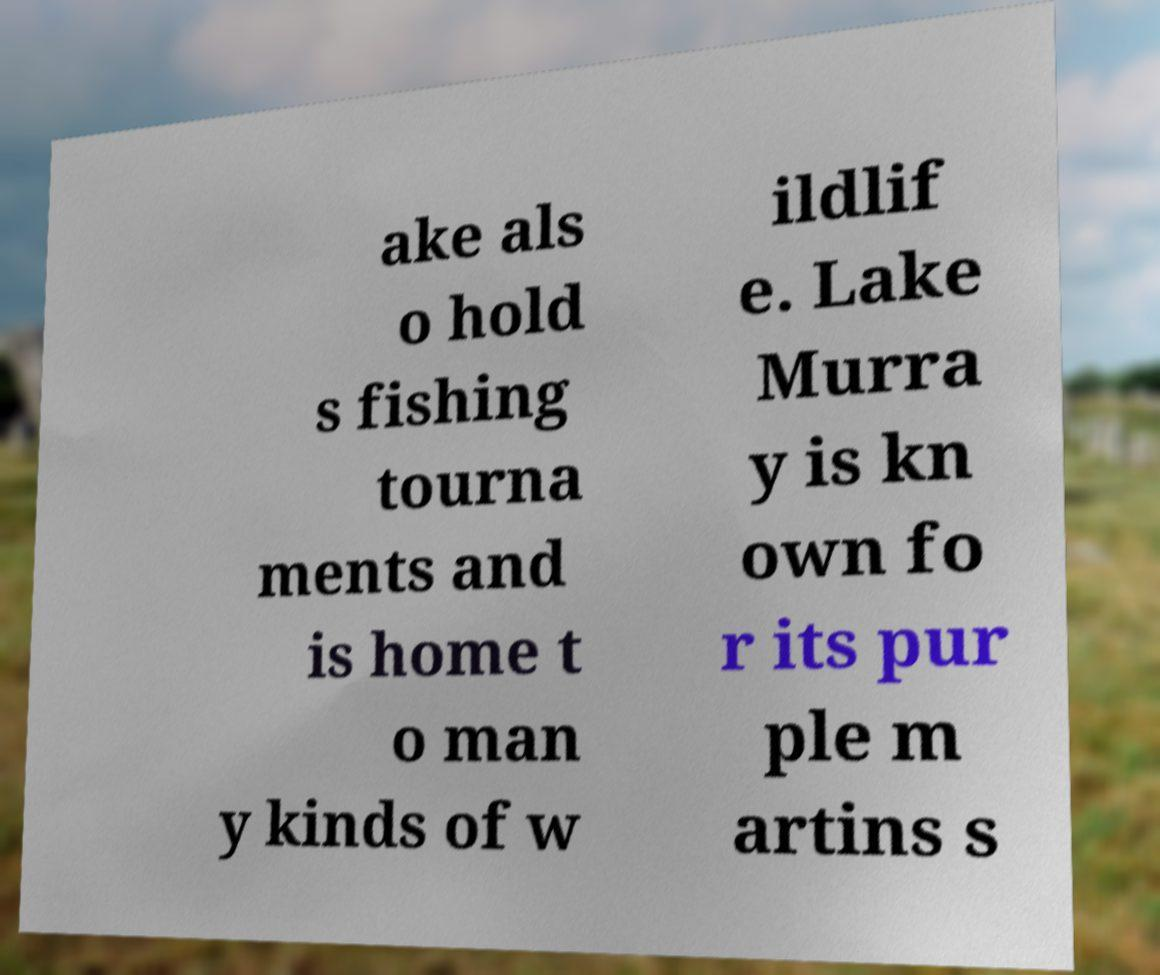Could you extract and type out the text from this image? ake als o hold s fishing tourna ments and is home t o man y kinds of w ildlif e. Lake Murra y is kn own fo r its pur ple m artins s 